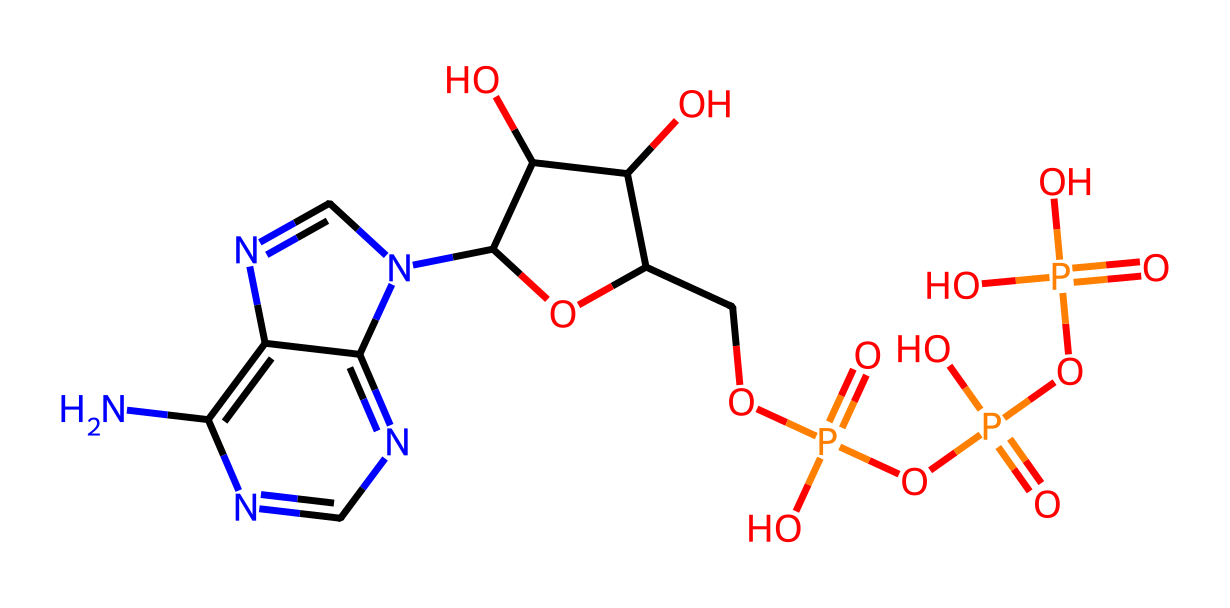How many phosphorus atoms are present in ATP? To determine the number of phosphorus atoms, we examine the chemical structure. In the provided SMILES representation, we look specifically for the 'P' symbol that represents phosphorus. By counting the occurrences of 'P', we find there are 3 distinct phosphorus atoms in the structure.
Answer: 3 What type of compound is adenosine triphosphate classified as? The SMILES representation indicates the presence of adenosine and multiple phosphate groups. Adenosine triphosphate is specifically classified as a nucleotide because it consists of a nitrogenous base (adenine), a sugar (ribose), and multiple phosphate groups.
Answer: nucleotide What is the total number of oxygen atoms in ATP? In the SMILES notation, we count the number of occurrences of the 'O' symbol, which stands for oxygen. By carefully analyzing the structure, we find there are 7 oxygen atoms in the adenosine triphosphate molecule.
Answer: 7 Which functional groups are prominently featured in ATP? The SMILES structure reveals multiple phosphate groups (indicated by the P atoms surrounded by O atoms) and a ribose sugar containing hydroxyl (-OH) groups. These phosphate groups are a hallmark of energy-carrying molecules, characterizing ATP with acyclic phosphate functional groups.
Answer: phosphate groups What role do the phosphate groups play in ATP's function? The presence of the phosphate groups, which have high-energy bonds between them, allows ATP to undergo hydrolysis, releasing energy that can be used for various cellular processes. The energy release is due to the instability of the bonds between the negatively charged phosphate groups.
Answer: energy carrier 